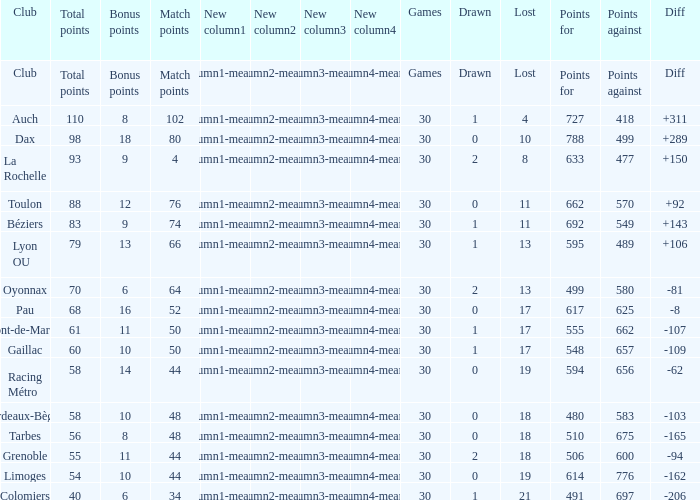What is the number of games for a club that has 34 match points? 30.0. 